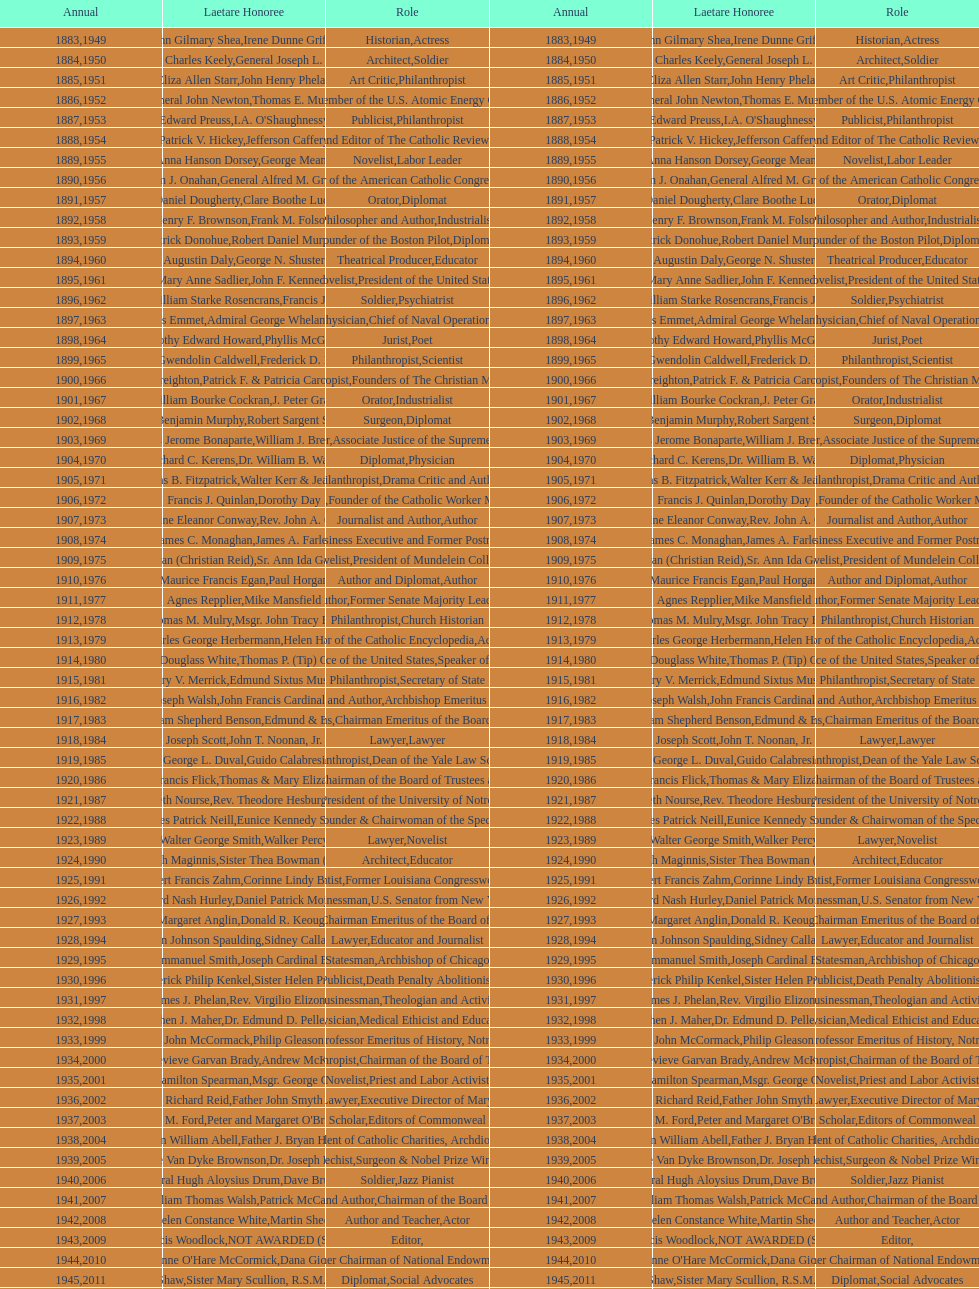How many attorneys have received the award between 1883 and 2014? 5. 